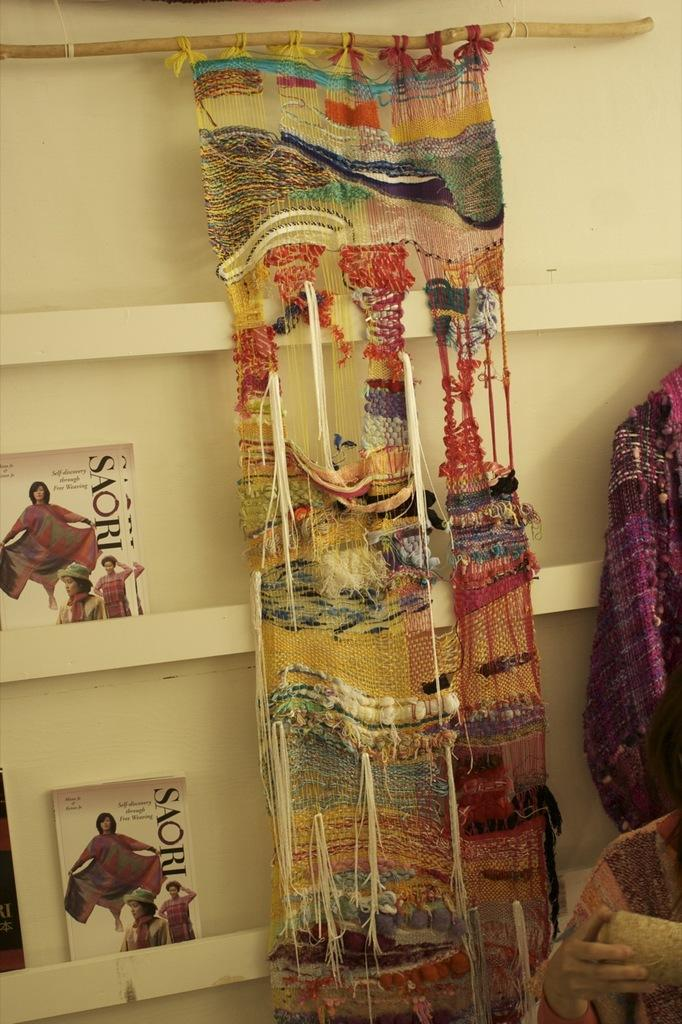What is on the shelf in the image? There is a shelf with flyers in the image. What can be seen hanging in the image? There is a cloth hanged in the image. What type of items are on the right side of the image? Clothes are visible on the right side of the image. What is the person in the image doing? There is a person holding an object in the image. What type of operation is being performed on the person in the image? There is no operation being performed on the person in the image; they are simply holding an object. What type of scene is depicted in the image? The image does not depict a specific scene; it shows a shelf, a cloth, clothes, and a person holding an object. What color is the copper in the image? There is no copper present in the image. 